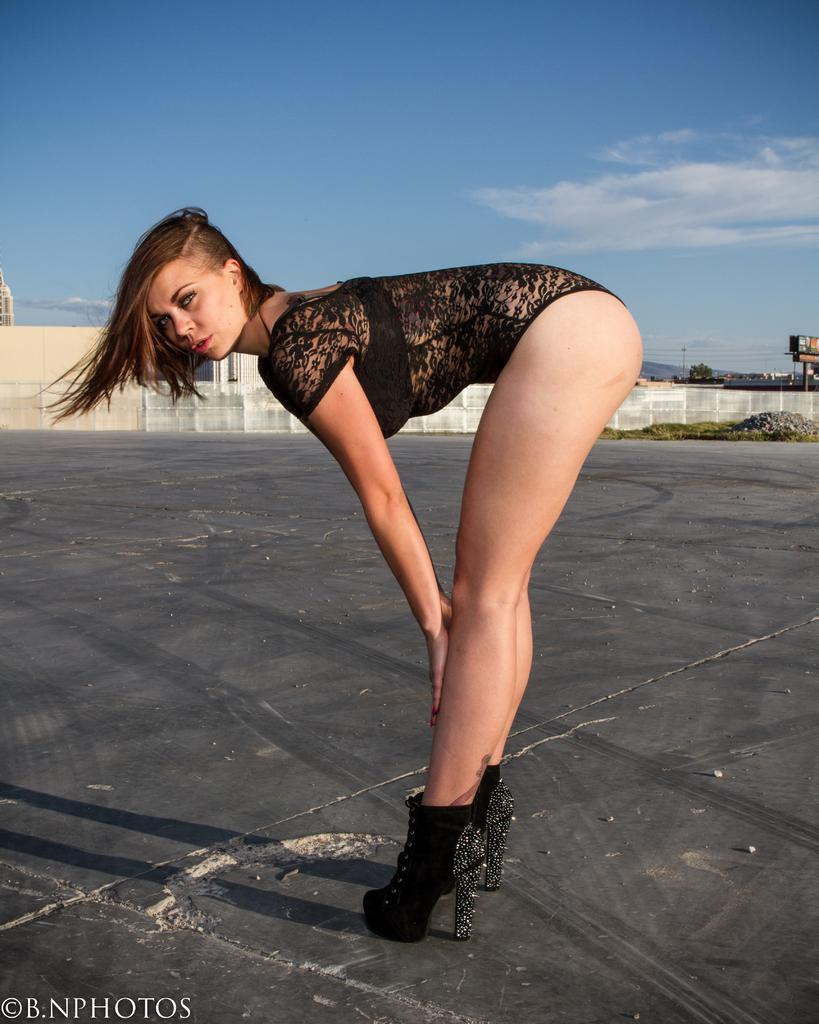Who is present in the image? There is a woman in the image. What is the woman wearing? The woman is wearing a black dress and black shoes. Where is the woman standing? The woman is standing on the ground. What can be seen in the background of the image? There are trees, buildings, and the sky visible in the background of the image. How many stitches does the woman have on her dress in the image? There is no information about the stitches on the woman's dress in the image, as the facts provided only mention the color of her dress and shoes. 